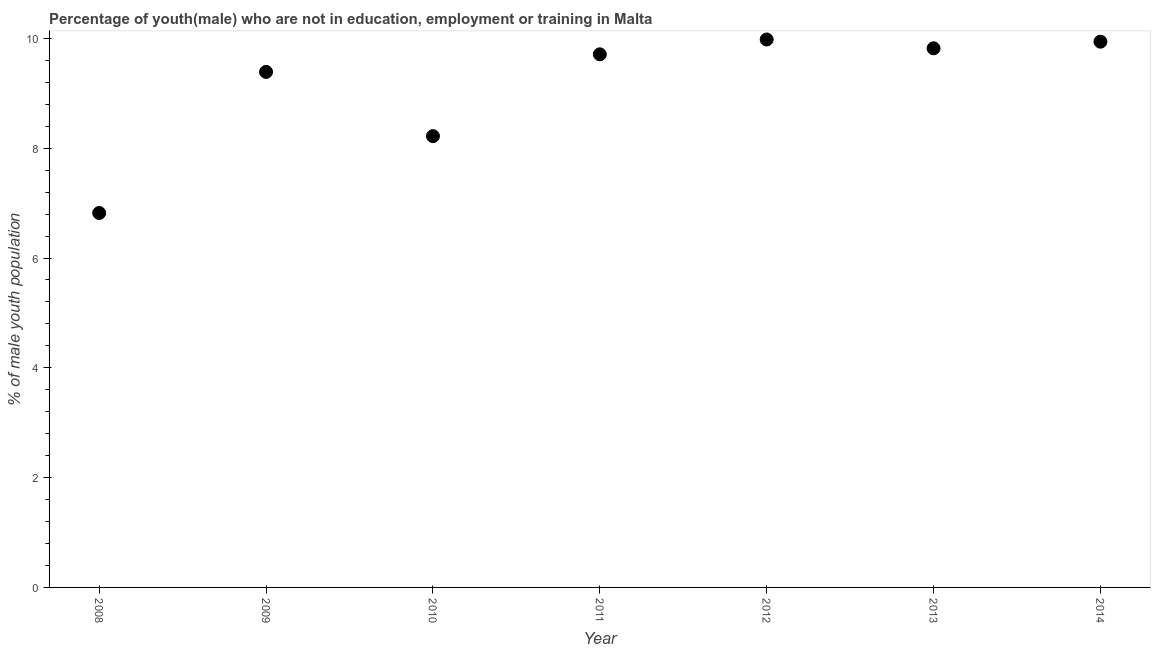What is the unemployed male youth population in 2010?
Make the answer very short. 8.22. Across all years, what is the maximum unemployed male youth population?
Ensure brevity in your answer.  9.98. Across all years, what is the minimum unemployed male youth population?
Make the answer very short. 6.82. What is the sum of the unemployed male youth population?
Give a very brief answer. 63.88. What is the difference between the unemployed male youth population in 2008 and 2009?
Make the answer very short. -2.57. What is the average unemployed male youth population per year?
Provide a short and direct response. 9.13. What is the median unemployed male youth population?
Make the answer very short. 9.71. What is the ratio of the unemployed male youth population in 2012 to that in 2013?
Your answer should be compact. 1.02. Is the unemployed male youth population in 2011 less than that in 2013?
Your response must be concise. Yes. Is the difference between the unemployed male youth population in 2011 and 2013 greater than the difference between any two years?
Offer a very short reply. No. What is the difference between the highest and the second highest unemployed male youth population?
Ensure brevity in your answer.  0.04. Is the sum of the unemployed male youth population in 2013 and 2014 greater than the maximum unemployed male youth population across all years?
Provide a short and direct response. Yes. What is the difference between the highest and the lowest unemployed male youth population?
Offer a terse response. 3.16. In how many years, is the unemployed male youth population greater than the average unemployed male youth population taken over all years?
Give a very brief answer. 5. Does the unemployed male youth population monotonically increase over the years?
Ensure brevity in your answer.  No. What is the difference between two consecutive major ticks on the Y-axis?
Give a very brief answer. 2. Are the values on the major ticks of Y-axis written in scientific E-notation?
Give a very brief answer. No. Does the graph contain grids?
Make the answer very short. No. What is the title of the graph?
Keep it short and to the point. Percentage of youth(male) who are not in education, employment or training in Malta. What is the label or title of the X-axis?
Give a very brief answer. Year. What is the label or title of the Y-axis?
Ensure brevity in your answer.  % of male youth population. What is the % of male youth population in 2008?
Your answer should be compact. 6.82. What is the % of male youth population in 2009?
Your response must be concise. 9.39. What is the % of male youth population in 2010?
Your response must be concise. 8.22. What is the % of male youth population in 2011?
Ensure brevity in your answer.  9.71. What is the % of male youth population in 2012?
Provide a short and direct response. 9.98. What is the % of male youth population in 2013?
Your answer should be compact. 9.82. What is the % of male youth population in 2014?
Make the answer very short. 9.94. What is the difference between the % of male youth population in 2008 and 2009?
Your response must be concise. -2.57. What is the difference between the % of male youth population in 2008 and 2011?
Give a very brief answer. -2.89. What is the difference between the % of male youth population in 2008 and 2012?
Make the answer very short. -3.16. What is the difference between the % of male youth population in 2008 and 2013?
Keep it short and to the point. -3. What is the difference between the % of male youth population in 2008 and 2014?
Offer a terse response. -3.12. What is the difference between the % of male youth population in 2009 and 2010?
Your response must be concise. 1.17. What is the difference between the % of male youth population in 2009 and 2011?
Give a very brief answer. -0.32. What is the difference between the % of male youth population in 2009 and 2012?
Your answer should be compact. -0.59. What is the difference between the % of male youth population in 2009 and 2013?
Ensure brevity in your answer.  -0.43. What is the difference between the % of male youth population in 2009 and 2014?
Provide a short and direct response. -0.55. What is the difference between the % of male youth population in 2010 and 2011?
Offer a very short reply. -1.49. What is the difference between the % of male youth population in 2010 and 2012?
Offer a terse response. -1.76. What is the difference between the % of male youth population in 2010 and 2014?
Provide a short and direct response. -1.72. What is the difference between the % of male youth population in 2011 and 2012?
Offer a terse response. -0.27. What is the difference between the % of male youth population in 2011 and 2013?
Make the answer very short. -0.11. What is the difference between the % of male youth population in 2011 and 2014?
Provide a succinct answer. -0.23. What is the difference between the % of male youth population in 2012 and 2013?
Your answer should be compact. 0.16. What is the difference between the % of male youth population in 2012 and 2014?
Your response must be concise. 0.04. What is the difference between the % of male youth population in 2013 and 2014?
Your response must be concise. -0.12. What is the ratio of the % of male youth population in 2008 to that in 2009?
Provide a succinct answer. 0.73. What is the ratio of the % of male youth population in 2008 to that in 2010?
Your answer should be very brief. 0.83. What is the ratio of the % of male youth population in 2008 to that in 2011?
Provide a succinct answer. 0.7. What is the ratio of the % of male youth population in 2008 to that in 2012?
Your response must be concise. 0.68. What is the ratio of the % of male youth population in 2008 to that in 2013?
Your answer should be very brief. 0.69. What is the ratio of the % of male youth population in 2008 to that in 2014?
Offer a very short reply. 0.69. What is the ratio of the % of male youth population in 2009 to that in 2010?
Your answer should be very brief. 1.14. What is the ratio of the % of male youth population in 2009 to that in 2012?
Keep it short and to the point. 0.94. What is the ratio of the % of male youth population in 2009 to that in 2013?
Offer a terse response. 0.96. What is the ratio of the % of male youth population in 2009 to that in 2014?
Your response must be concise. 0.94. What is the ratio of the % of male youth population in 2010 to that in 2011?
Give a very brief answer. 0.85. What is the ratio of the % of male youth population in 2010 to that in 2012?
Your answer should be compact. 0.82. What is the ratio of the % of male youth population in 2010 to that in 2013?
Your answer should be very brief. 0.84. What is the ratio of the % of male youth population in 2010 to that in 2014?
Provide a short and direct response. 0.83. What is the ratio of the % of male youth population in 2011 to that in 2012?
Ensure brevity in your answer.  0.97. What is the ratio of the % of male youth population in 2011 to that in 2013?
Your answer should be very brief. 0.99. What is the ratio of the % of male youth population in 2012 to that in 2013?
Offer a very short reply. 1.02. What is the ratio of the % of male youth population in 2013 to that in 2014?
Your answer should be compact. 0.99. 